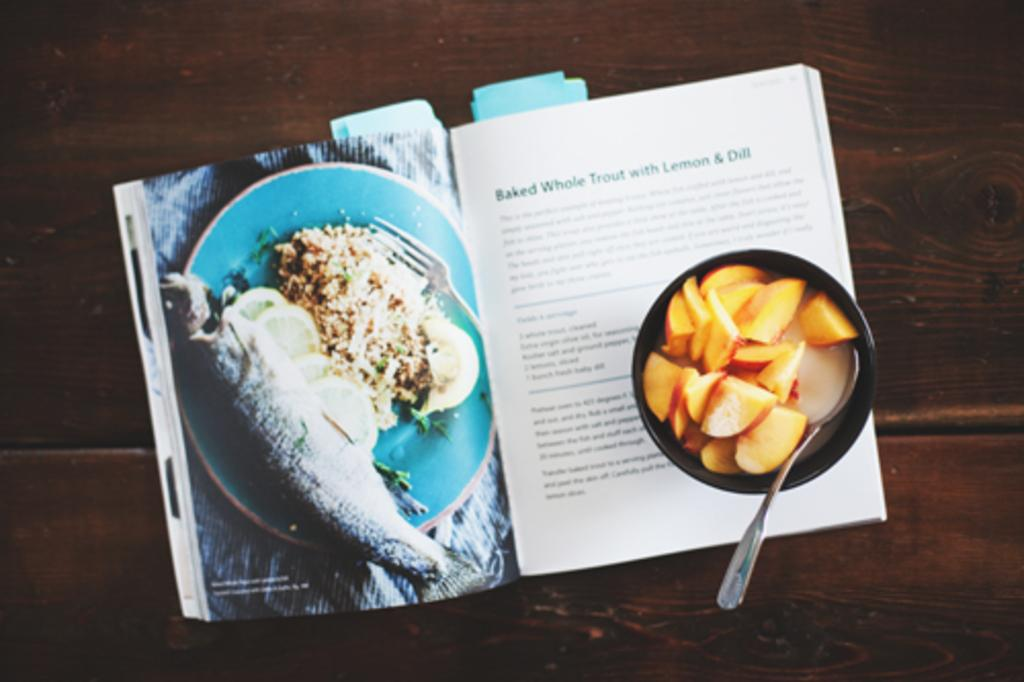<image>
Summarize the visual content of the image. A cookbook opened to the recipe Baked Whole Trout with Lemon & dill and a cup of peaches.. 